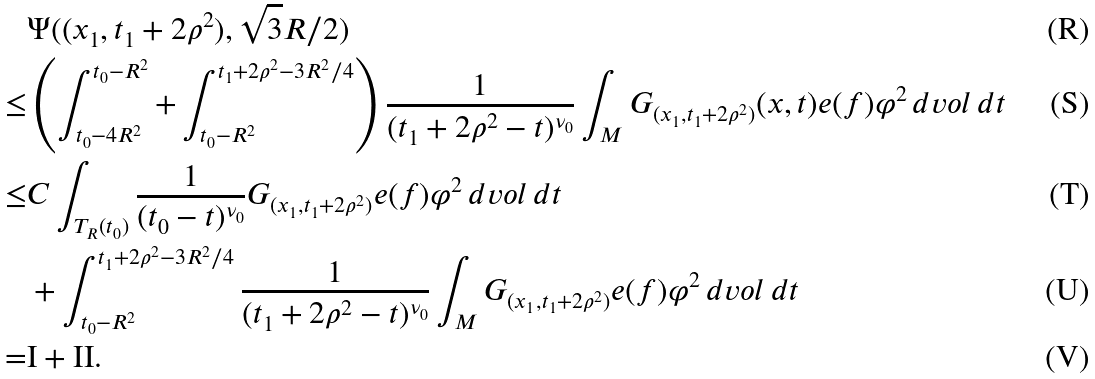Convert formula to latex. <formula><loc_0><loc_0><loc_500><loc_500>& \Psi ( ( x _ { 1 } , t _ { 1 } + 2 \rho ^ { 2 } ) , \sqrt { 3 } R / 2 ) \\ \leq & \left ( \int _ { t _ { 0 } - 4 R ^ { 2 } } ^ { t _ { 0 } - R ^ { 2 } } + \int _ { t _ { 0 } - R ^ { 2 } } ^ { t _ { 1 } + 2 \rho ^ { 2 } - 3 R ^ { 2 } / 4 } \right ) \frac { 1 } { ( t _ { 1 } + 2 \rho ^ { 2 } - t ) ^ { \nu _ { 0 } } } \int _ { M } G _ { ( x _ { 1 } , t _ { 1 } + 2 \rho ^ { 2 } ) } ( x , t ) e ( f ) \varphi ^ { 2 } \, d v o l \, d t \\ \leq & C \int _ { T _ { R } ( t _ { 0 } ) } \frac { 1 } { ( t _ { 0 } - t ) ^ { \nu _ { 0 } } } G _ { ( x _ { 1 } , t _ { 1 } + 2 \rho ^ { 2 } ) } e ( f ) \varphi ^ { 2 } \, d v o l \, d t \\ & + \int _ { t _ { 0 } - R ^ { 2 } } ^ { t _ { 1 } + 2 \rho ^ { 2 } - 3 R ^ { 2 } / 4 } \frac { 1 } { ( t _ { 1 } + 2 \rho ^ { 2 } - t ) ^ { \nu _ { 0 } } } \int _ { M } G _ { ( x _ { 1 } , t _ { 1 } + 2 \rho ^ { 2 } ) } e ( f ) \varphi ^ { 2 } \, d v o l \, d t \\ = & \text {I} + \text {II} .</formula> 